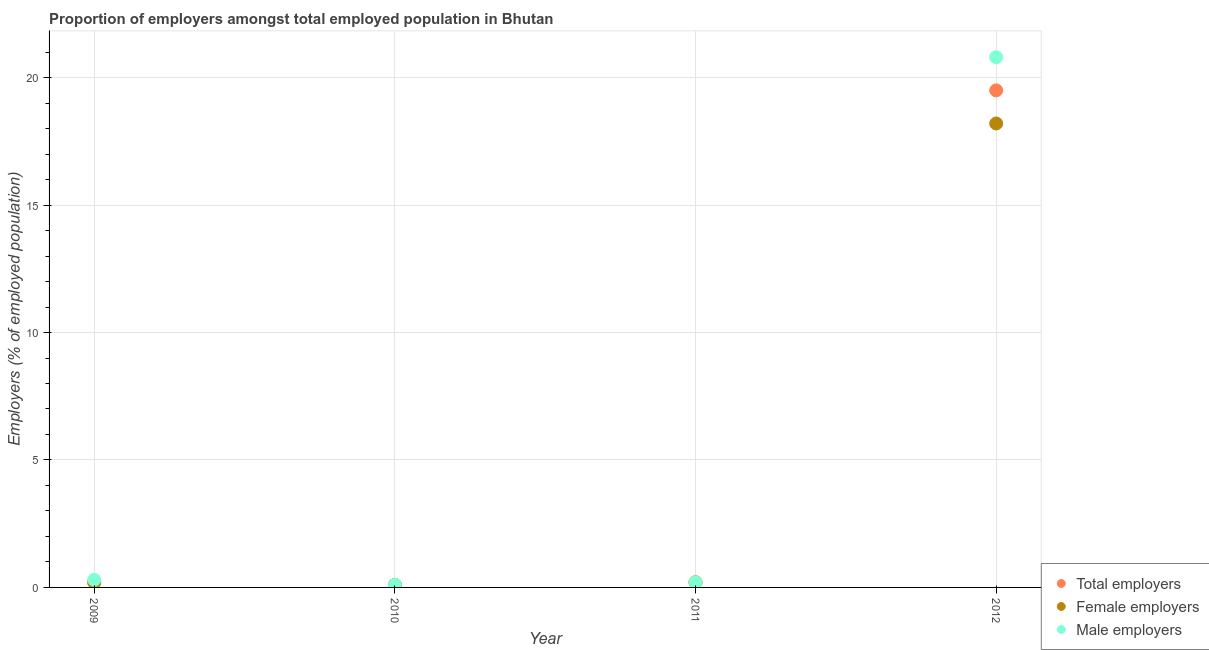Is the number of dotlines equal to the number of legend labels?
Ensure brevity in your answer.  Yes. What is the percentage of total employers in 2009?
Keep it short and to the point. 0.2. Across all years, what is the minimum percentage of total employers?
Offer a terse response. 0.1. In which year was the percentage of female employers maximum?
Keep it short and to the point. 2012. What is the total percentage of female employers in the graph?
Provide a succinct answer. 18.7. What is the difference between the percentage of total employers in 2009 and that in 2012?
Make the answer very short. -19.3. What is the difference between the percentage of male employers in 2010 and the percentage of female employers in 2009?
Make the answer very short. -0.1. What is the average percentage of total employers per year?
Provide a succinct answer. 5. In the year 2009, what is the difference between the percentage of total employers and percentage of female employers?
Offer a very short reply. 0. What is the ratio of the percentage of male employers in 2009 to that in 2012?
Provide a short and direct response. 0.01. Is the percentage of total employers in 2011 less than that in 2012?
Ensure brevity in your answer.  Yes. What is the difference between the highest and the second highest percentage of male employers?
Provide a succinct answer. 20.5. What is the difference between the highest and the lowest percentage of total employers?
Provide a short and direct response. 19.4. In how many years, is the percentage of female employers greater than the average percentage of female employers taken over all years?
Make the answer very short. 1. Is the sum of the percentage of female employers in 2010 and 2011 greater than the maximum percentage of male employers across all years?
Provide a succinct answer. No. Does the percentage of total employers monotonically increase over the years?
Your answer should be compact. No. Is the percentage of total employers strictly greater than the percentage of female employers over the years?
Make the answer very short. No. Is the percentage of female employers strictly less than the percentage of male employers over the years?
Provide a short and direct response. No. How many dotlines are there?
Your answer should be very brief. 3. What is the difference between two consecutive major ticks on the Y-axis?
Make the answer very short. 5. Are the values on the major ticks of Y-axis written in scientific E-notation?
Offer a very short reply. No. Does the graph contain any zero values?
Your response must be concise. No. Does the graph contain grids?
Offer a very short reply. Yes. Where does the legend appear in the graph?
Provide a succinct answer. Bottom right. What is the title of the graph?
Your answer should be compact. Proportion of employers amongst total employed population in Bhutan. Does "Coal sources" appear as one of the legend labels in the graph?
Provide a succinct answer. No. What is the label or title of the Y-axis?
Ensure brevity in your answer.  Employers (% of employed population). What is the Employers (% of employed population) of Total employers in 2009?
Provide a succinct answer. 0.2. What is the Employers (% of employed population) in Female employers in 2009?
Your response must be concise. 0.2. What is the Employers (% of employed population) of Male employers in 2009?
Your response must be concise. 0.3. What is the Employers (% of employed population) in Total employers in 2010?
Your answer should be compact. 0.1. What is the Employers (% of employed population) of Female employers in 2010?
Your answer should be very brief. 0.1. What is the Employers (% of employed population) in Male employers in 2010?
Keep it short and to the point. 0.1. What is the Employers (% of employed population) in Total employers in 2011?
Provide a short and direct response. 0.2. What is the Employers (% of employed population) in Female employers in 2011?
Provide a short and direct response. 0.2. What is the Employers (% of employed population) of Male employers in 2011?
Provide a succinct answer. 0.2. What is the Employers (% of employed population) of Total employers in 2012?
Your answer should be very brief. 19.5. What is the Employers (% of employed population) of Female employers in 2012?
Provide a succinct answer. 18.2. What is the Employers (% of employed population) of Male employers in 2012?
Offer a very short reply. 20.8. Across all years, what is the maximum Employers (% of employed population) of Female employers?
Provide a succinct answer. 18.2. Across all years, what is the maximum Employers (% of employed population) in Male employers?
Your answer should be compact. 20.8. Across all years, what is the minimum Employers (% of employed population) of Total employers?
Offer a terse response. 0.1. Across all years, what is the minimum Employers (% of employed population) in Female employers?
Provide a succinct answer. 0.1. Across all years, what is the minimum Employers (% of employed population) in Male employers?
Offer a terse response. 0.1. What is the total Employers (% of employed population) of Total employers in the graph?
Give a very brief answer. 20. What is the total Employers (% of employed population) in Female employers in the graph?
Offer a very short reply. 18.7. What is the total Employers (% of employed population) in Male employers in the graph?
Give a very brief answer. 21.4. What is the difference between the Employers (% of employed population) of Total employers in 2009 and that in 2011?
Your answer should be compact. 0. What is the difference between the Employers (% of employed population) of Female employers in 2009 and that in 2011?
Provide a succinct answer. 0. What is the difference between the Employers (% of employed population) in Total employers in 2009 and that in 2012?
Give a very brief answer. -19.3. What is the difference between the Employers (% of employed population) in Female employers in 2009 and that in 2012?
Your answer should be compact. -18. What is the difference between the Employers (% of employed population) of Male employers in 2009 and that in 2012?
Keep it short and to the point. -20.5. What is the difference between the Employers (% of employed population) in Female employers in 2010 and that in 2011?
Keep it short and to the point. -0.1. What is the difference between the Employers (% of employed population) of Male employers in 2010 and that in 2011?
Provide a succinct answer. -0.1. What is the difference between the Employers (% of employed population) of Total employers in 2010 and that in 2012?
Provide a short and direct response. -19.4. What is the difference between the Employers (% of employed population) in Female employers in 2010 and that in 2012?
Keep it short and to the point. -18.1. What is the difference between the Employers (% of employed population) of Male employers in 2010 and that in 2012?
Offer a very short reply. -20.7. What is the difference between the Employers (% of employed population) in Total employers in 2011 and that in 2012?
Give a very brief answer. -19.3. What is the difference between the Employers (% of employed population) in Female employers in 2011 and that in 2012?
Give a very brief answer. -18. What is the difference between the Employers (% of employed population) in Male employers in 2011 and that in 2012?
Your response must be concise. -20.6. What is the difference between the Employers (% of employed population) of Total employers in 2009 and the Employers (% of employed population) of Female employers in 2010?
Offer a very short reply. 0.1. What is the difference between the Employers (% of employed population) in Total employers in 2009 and the Employers (% of employed population) in Male employers in 2010?
Offer a very short reply. 0.1. What is the difference between the Employers (% of employed population) in Total employers in 2009 and the Employers (% of employed population) in Female employers in 2011?
Keep it short and to the point. 0. What is the difference between the Employers (% of employed population) of Total employers in 2009 and the Employers (% of employed population) of Male employers in 2011?
Keep it short and to the point. 0. What is the difference between the Employers (% of employed population) in Total employers in 2009 and the Employers (% of employed population) in Male employers in 2012?
Give a very brief answer. -20.6. What is the difference between the Employers (% of employed population) in Female employers in 2009 and the Employers (% of employed population) in Male employers in 2012?
Provide a succinct answer. -20.6. What is the difference between the Employers (% of employed population) in Total employers in 2010 and the Employers (% of employed population) in Female employers in 2011?
Offer a terse response. -0.1. What is the difference between the Employers (% of employed population) of Total employers in 2010 and the Employers (% of employed population) of Female employers in 2012?
Give a very brief answer. -18.1. What is the difference between the Employers (% of employed population) in Total employers in 2010 and the Employers (% of employed population) in Male employers in 2012?
Ensure brevity in your answer.  -20.7. What is the difference between the Employers (% of employed population) of Female employers in 2010 and the Employers (% of employed population) of Male employers in 2012?
Provide a short and direct response. -20.7. What is the difference between the Employers (% of employed population) in Total employers in 2011 and the Employers (% of employed population) in Male employers in 2012?
Your answer should be compact. -20.6. What is the difference between the Employers (% of employed population) of Female employers in 2011 and the Employers (% of employed population) of Male employers in 2012?
Offer a very short reply. -20.6. What is the average Employers (% of employed population) in Total employers per year?
Make the answer very short. 5. What is the average Employers (% of employed population) in Female employers per year?
Give a very brief answer. 4.67. What is the average Employers (% of employed population) of Male employers per year?
Your response must be concise. 5.35. In the year 2009, what is the difference between the Employers (% of employed population) in Female employers and Employers (% of employed population) in Male employers?
Ensure brevity in your answer.  -0.1. In the year 2010, what is the difference between the Employers (% of employed population) in Total employers and Employers (% of employed population) in Female employers?
Offer a terse response. 0. In the year 2010, what is the difference between the Employers (% of employed population) of Total employers and Employers (% of employed population) of Male employers?
Keep it short and to the point. 0. In the year 2010, what is the difference between the Employers (% of employed population) in Female employers and Employers (% of employed population) in Male employers?
Ensure brevity in your answer.  0. In the year 2011, what is the difference between the Employers (% of employed population) of Total employers and Employers (% of employed population) of Male employers?
Offer a terse response. 0. In the year 2012, what is the difference between the Employers (% of employed population) of Total employers and Employers (% of employed population) of Female employers?
Your answer should be very brief. 1.3. In the year 2012, what is the difference between the Employers (% of employed population) of Total employers and Employers (% of employed population) of Male employers?
Offer a very short reply. -1.3. What is the ratio of the Employers (% of employed population) in Total employers in 2009 to that in 2010?
Offer a terse response. 2. What is the ratio of the Employers (% of employed population) in Female employers in 2009 to that in 2010?
Your response must be concise. 2. What is the ratio of the Employers (% of employed population) of Female employers in 2009 to that in 2011?
Ensure brevity in your answer.  1. What is the ratio of the Employers (% of employed population) of Total employers in 2009 to that in 2012?
Make the answer very short. 0.01. What is the ratio of the Employers (% of employed population) in Female employers in 2009 to that in 2012?
Ensure brevity in your answer.  0.01. What is the ratio of the Employers (% of employed population) in Male employers in 2009 to that in 2012?
Your answer should be very brief. 0.01. What is the ratio of the Employers (% of employed population) of Total employers in 2010 to that in 2012?
Make the answer very short. 0.01. What is the ratio of the Employers (% of employed population) in Female employers in 2010 to that in 2012?
Your answer should be compact. 0.01. What is the ratio of the Employers (% of employed population) of Male employers in 2010 to that in 2012?
Your response must be concise. 0. What is the ratio of the Employers (% of employed population) in Total employers in 2011 to that in 2012?
Your response must be concise. 0.01. What is the ratio of the Employers (% of employed population) in Female employers in 2011 to that in 2012?
Your answer should be very brief. 0.01. What is the ratio of the Employers (% of employed population) of Male employers in 2011 to that in 2012?
Keep it short and to the point. 0.01. What is the difference between the highest and the second highest Employers (% of employed population) in Total employers?
Give a very brief answer. 19.3. What is the difference between the highest and the second highest Employers (% of employed population) of Male employers?
Your response must be concise. 20.5. What is the difference between the highest and the lowest Employers (% of employed population) in Male employers?
Make the answer very short. 20.7. 